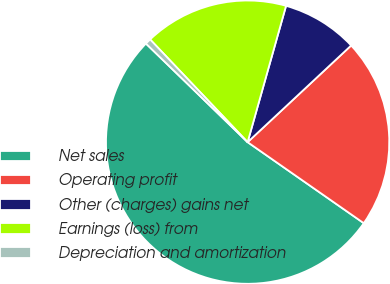Convert chart to OTSL. <chart><loc_0><loc_0><loc_500><loc_500><pie_chart><fcel>Net sales<fcel>Operating profit<fcel>Other (charges) gains net<fcel>Earnings (loss) from<fcel>Depreciation and amortization<nl><fcel>52.56%<fcel>21.65%<fcel>8.67%<fcel>16.46%<fcel>0.66%<nl></chart> 